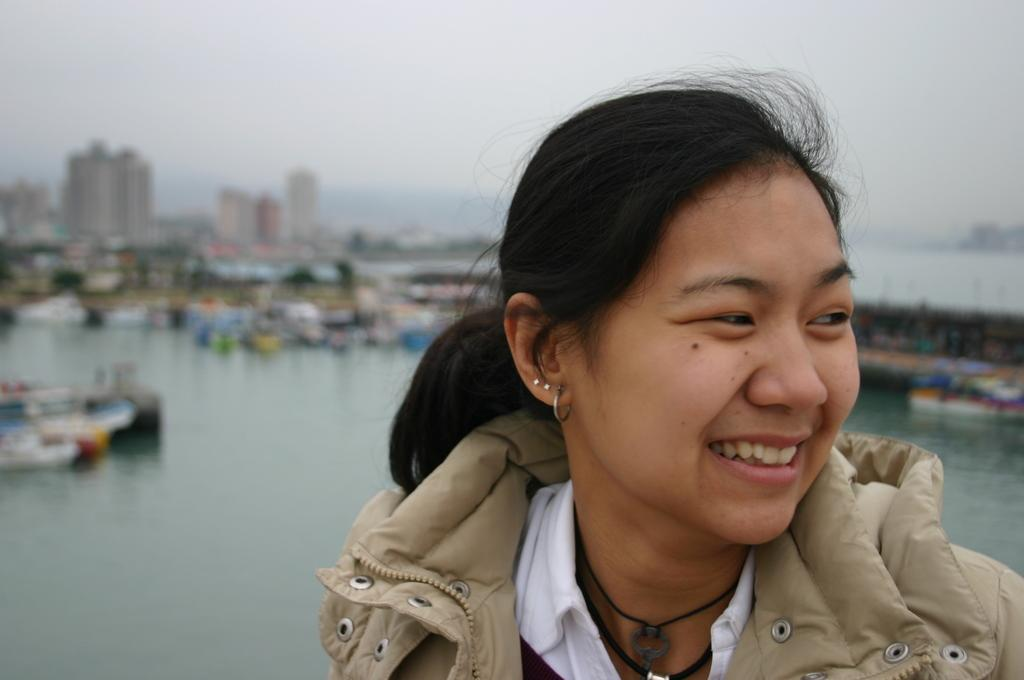Who is present in the image? There is a woman in the image. What is the woman wearing? The woman is wearing a jacket. What can be seen in the foreground of the image? There is water visible in the image. What is visible in the background of the image? There are buildings and the sky in the background of the image. Can you describe the quality of some items in the background? Some items in the background are blurred. What flavor of jail is the woman serving in the image? There is no jail or mention of a jail in the image. The woman is simply standing near water with buildings and the sky in the background. 